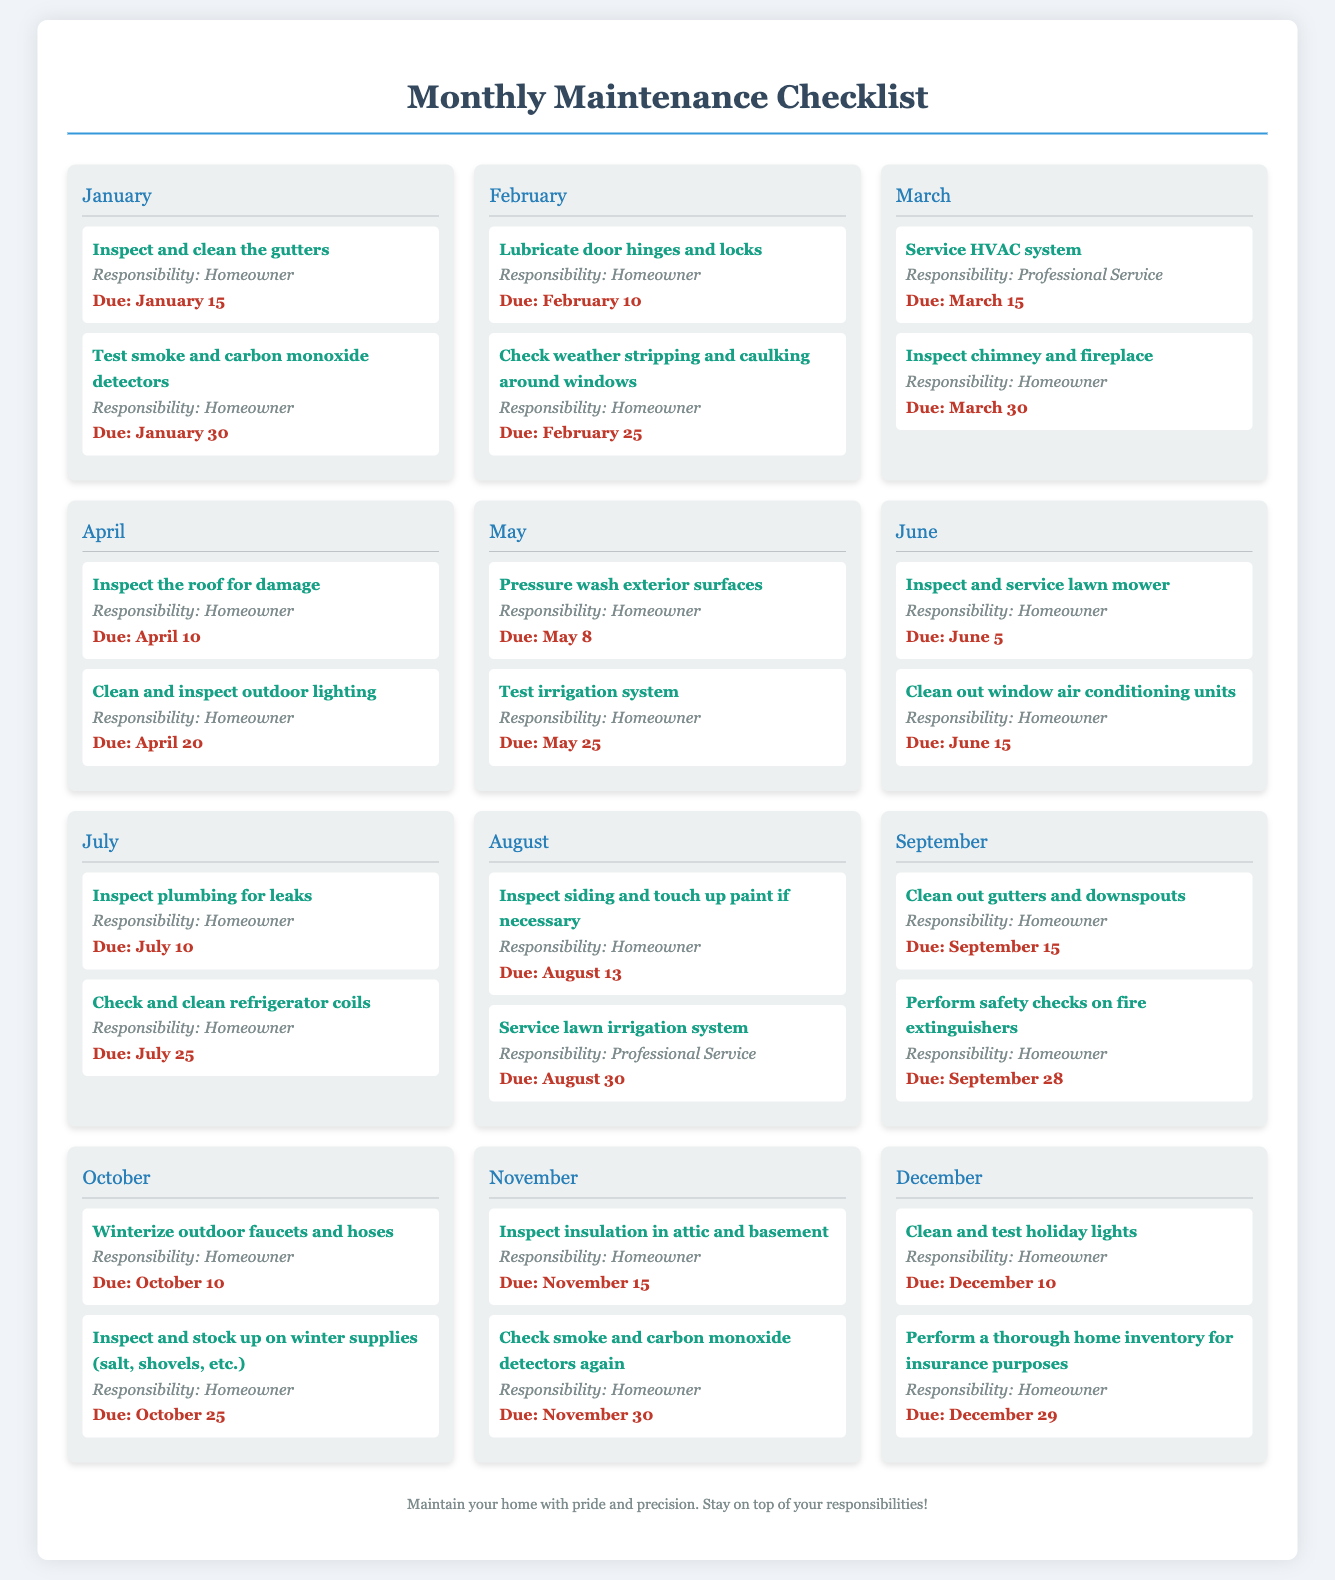What tasks need to be completed in January? The tasks listed for January are "Inspect and clean the gutters" and "Test smoke and carbon monoxide detectors."
Answer: Inspect and clean the gutters, Test smoke and carbon monoxide detectors What is the due date for inspecting the roof? The roof inspection task is due on April 10, according to the checklist.
Answer: April 10 Who is responsible for servicing the HVAC system? The responsibility for servicing the HVAC system is assigned to a professional service.
Answer: Professional Service How many tasks are due in November? There are two tasks listed in November: "Inspect insulation in attic and basement" and "Check smoke and carbon monoxide detectors again."
Answer: 2 Which month has the latest due date in this checklist? The task with the latest due date is in December, specifically "Perform a thorough home inventory for insurance purposes" due on December 29.
Answer: December 29 